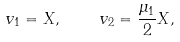Convert formula to latex. <formula><loc_0><loc_0><loc_500><loc_500>v _ { 1 } = X , \quad v _ { 2 } = \frac { \mu _ { 1 } } { 2 } X ,</formula> 